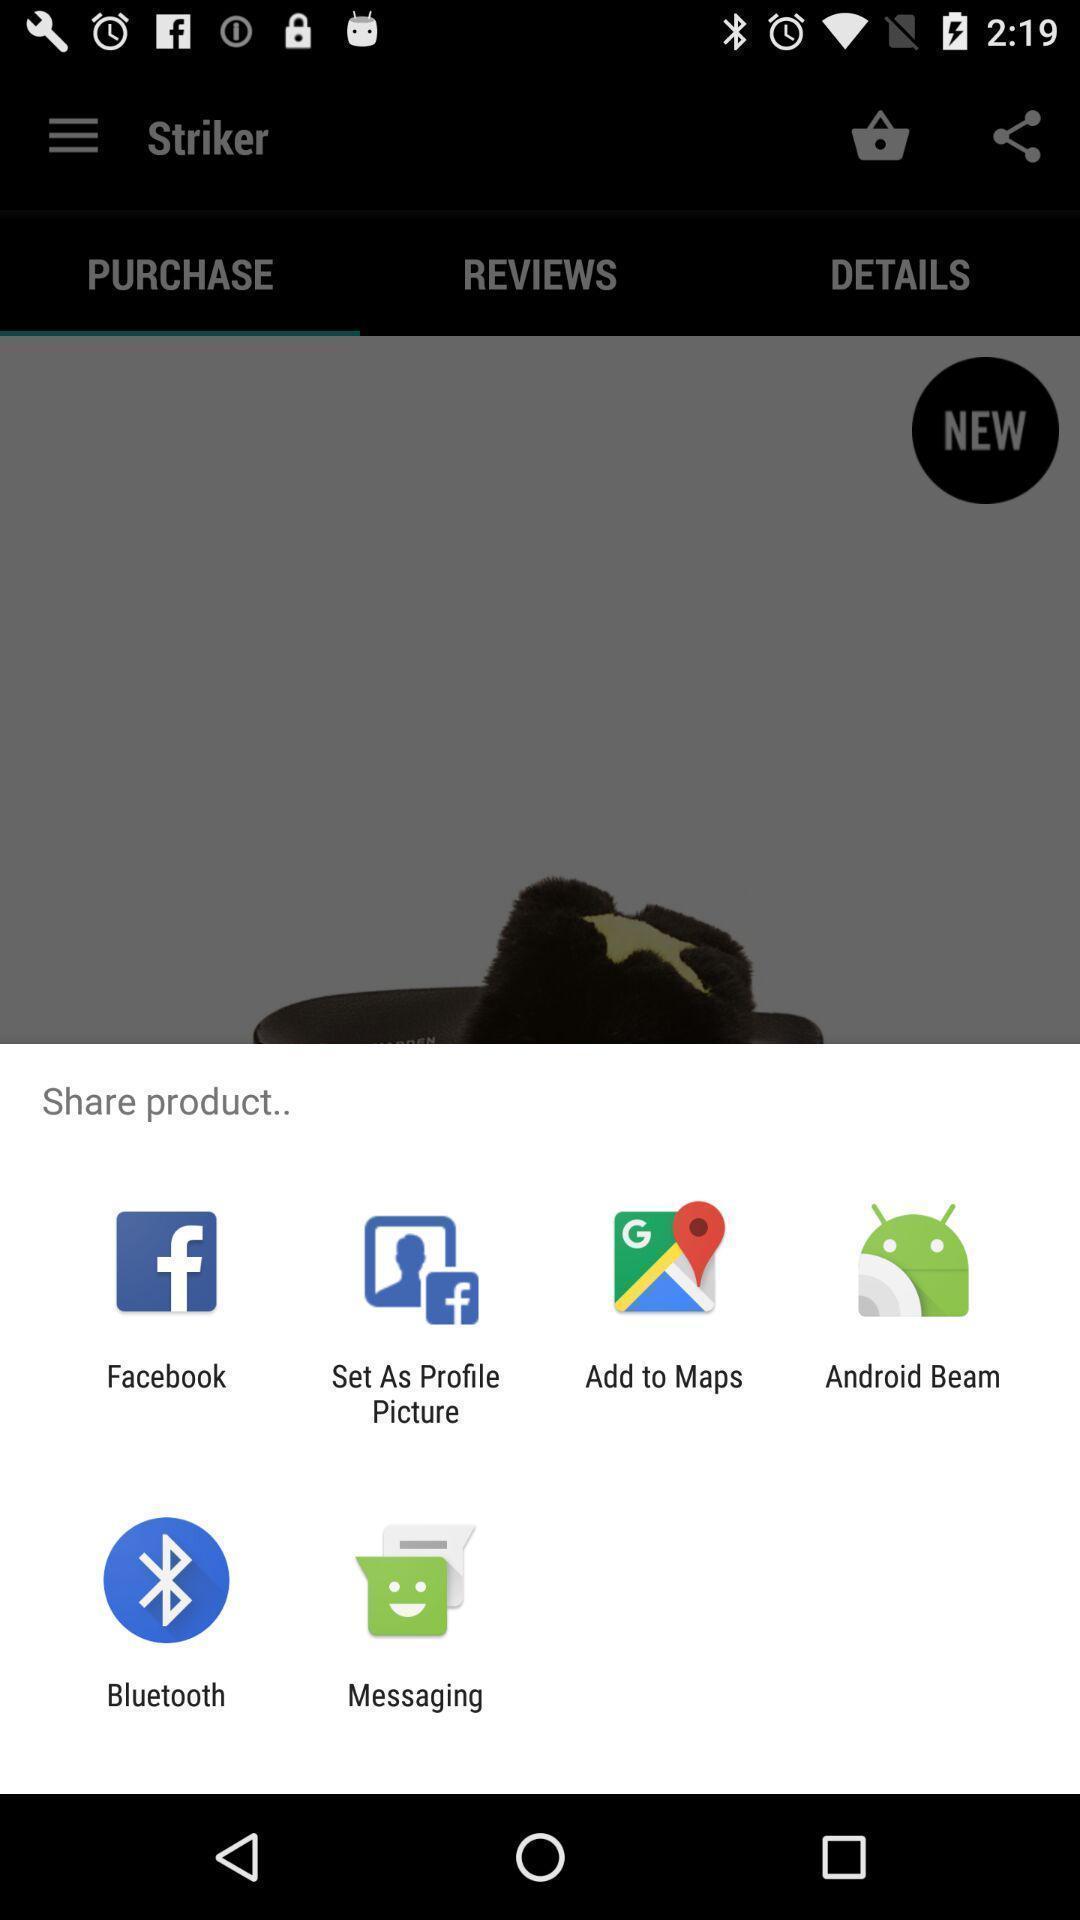Give me a narrative description of this picture. Popup showing options to share. 